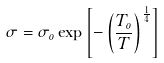<formula> <loc_0><loc_0><loc_500><loc_500>\sigma = \sigma _ { o } \exp \left [ - \left ( \frac { T _ { o } } { T } \right ) ^ { \frac { 1 } { 4 } } \right ]</formula> 